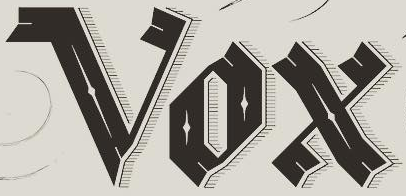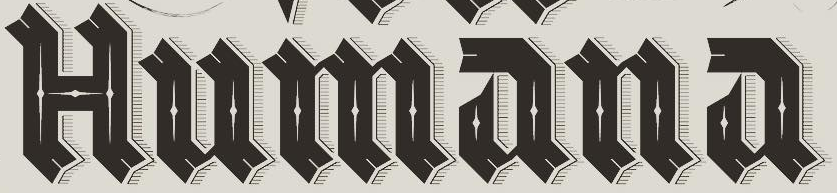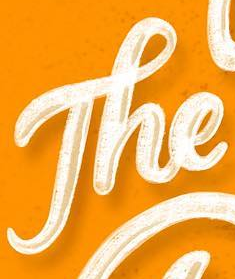Read the text content from these images in order, separated by a semicolon. Vox; Humana; The 